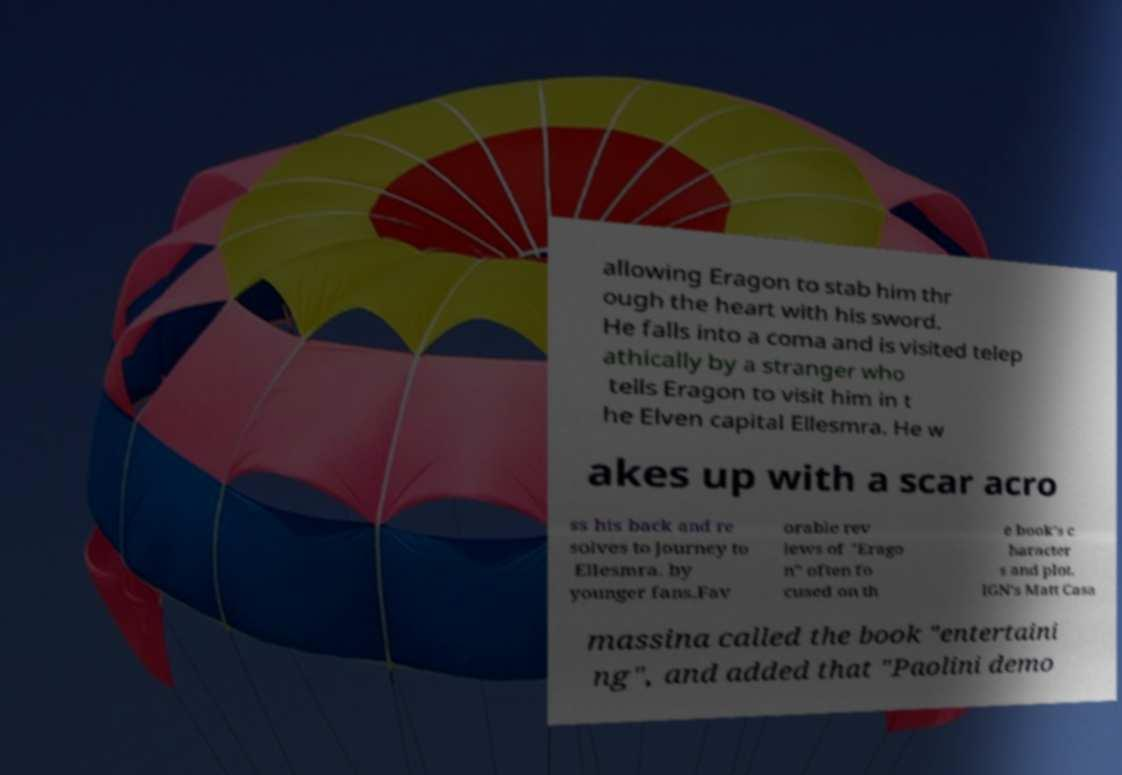What messages or text are displayed in this image? I need them in a readable, typed format. allowing Eragon to stab him thr ough the heart with his sword. He falls into a coma and is visited telep athically by a stranger who tells Eragon to visit him in t he Elven capital Ellesmra. He w akes up with a scar acro ss his back and re solves to journey to Ellesmra. by younger fans.Fav orable rev iews of "Erago n" often fo cused on th e book's c haracter s and plot. IGN's Matt Casa massina called the book "entertaini ng", and added that "Paolini demo 